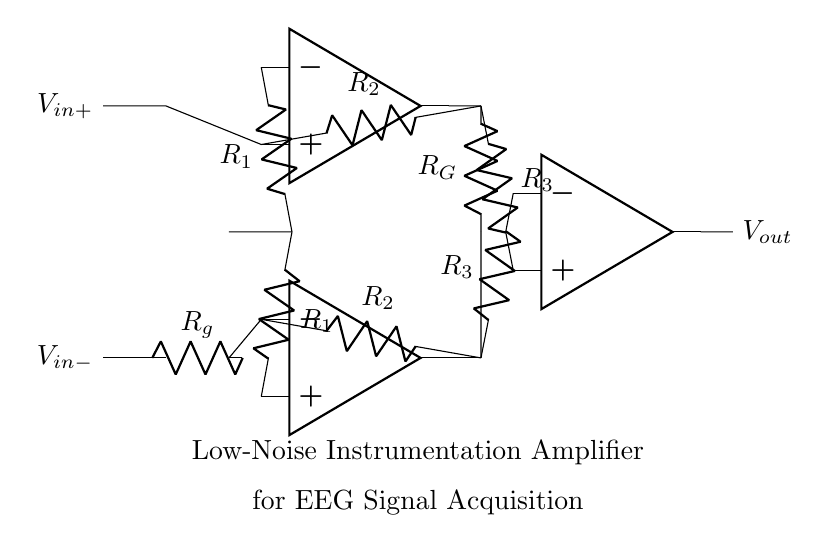What type of amplifier is depicted in this circuit? The circuit is labeled as a "Low-Noise Instrumentation Amplifier", indicating its specific design purpose related to signal amplification.
Answer: Low-Noise Instrumentation Amplifier How many operational amplifiers are used in this circuit? Counting the number of op-amp symbols present in the diagram shows that there are three operational amplifiers.
Answer: Three What is the purpose of the resistor labeled R_g? The resistor R_g typically sets the gain of the instrumentation amplifier and helps to provide the necessary feedback and stability in the circuit.
Answer: Gain setting What is the function of R_1 in this circuit? Resistor R_1 contributes to the gain of the amplifier by forming part of the differential input stage and establishing input impedance.
Answer: Gain contribution What is the output voltage denoted as in the diagram? The output voltage is represented by the label V_out, indicating the final output of the amplification process in this circuit.
Answer: V_out How do the resistors R_2 and R_G relate to the gain of the amplifier? Both R_2 and R_G play critical roles in setting the overall gain of the amplifier; the exact gain can be calculated based on their values and configuration in the circuit.
Answer: Set the gain What is the primary application of this type of amplifier? This amplifier is specifically designed for acquiring low-level signals from electrodes, such as those used in EEG (electroencephalogram) for brain activity monitoring.
Answer: EEG signal acquisition 